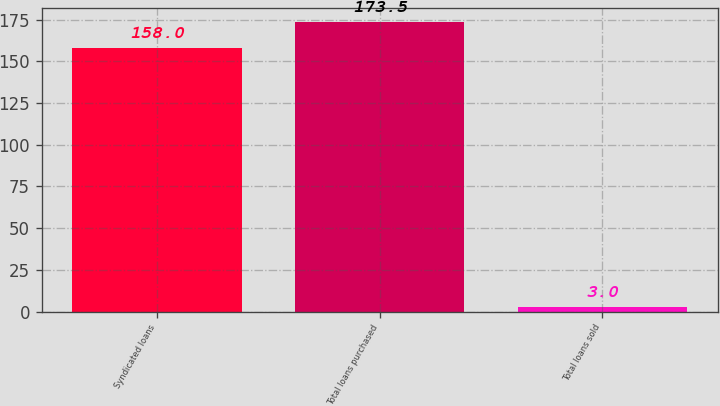<chart> <loc_0><loc_0><loc_500><loc_500><bar_chart><fcel>Syndicated loans<fcel>Total loans purchased<fcel>Total loans sold<nl><fcel>158<fcel>173.5<fcel>3<nl></chart> 